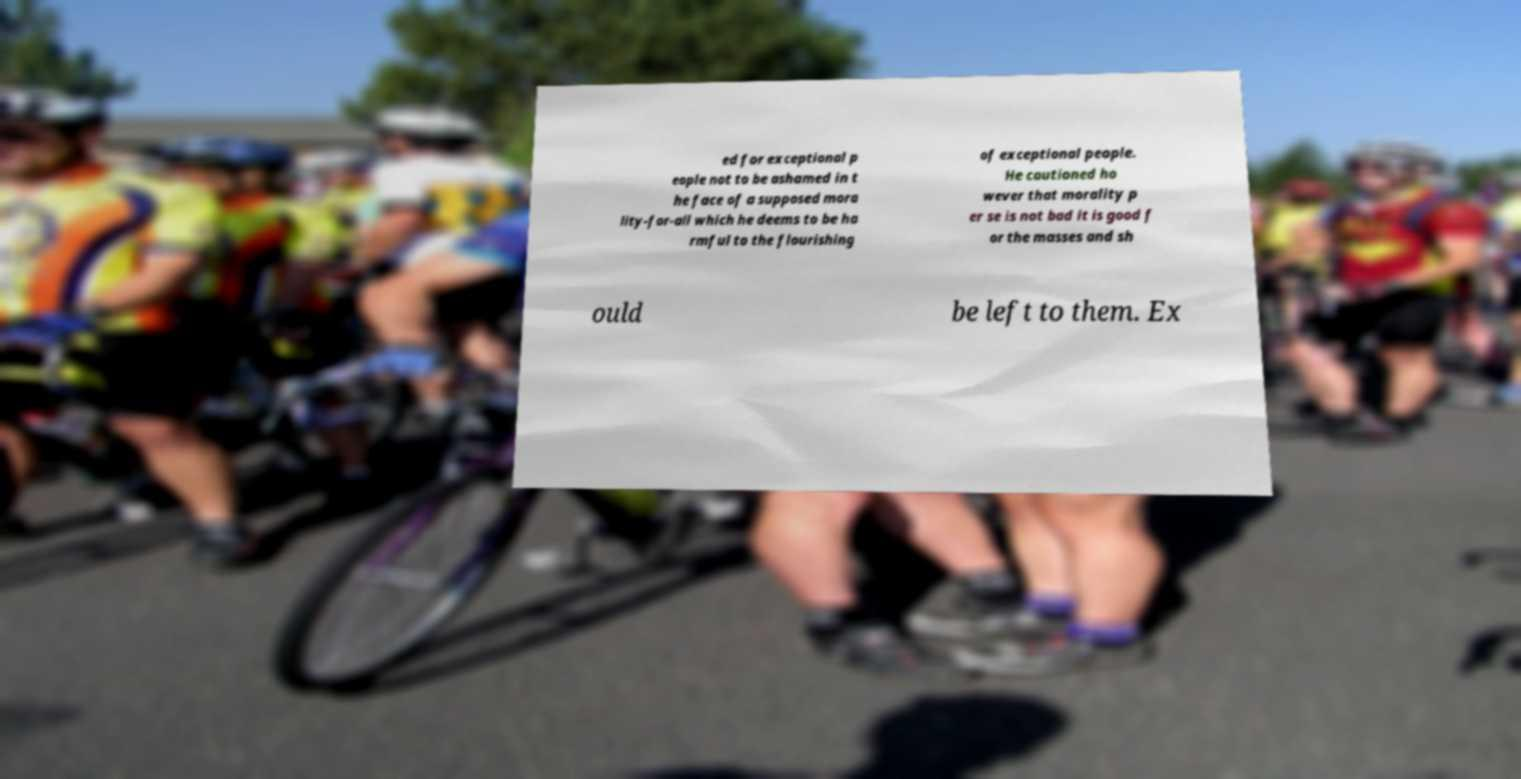There's text embedded in this image that I need extracted. Can you transcribe it verbatim? ed for exceptional p eople not to be ashamed in t he face of a supposed mora lity-for-all which he deems to be ha rmful to the flourishing of exceptional people. He cautioned ho wever that morality p er se is not bad it is good f or the masses and sh ould be left to them. Ex 